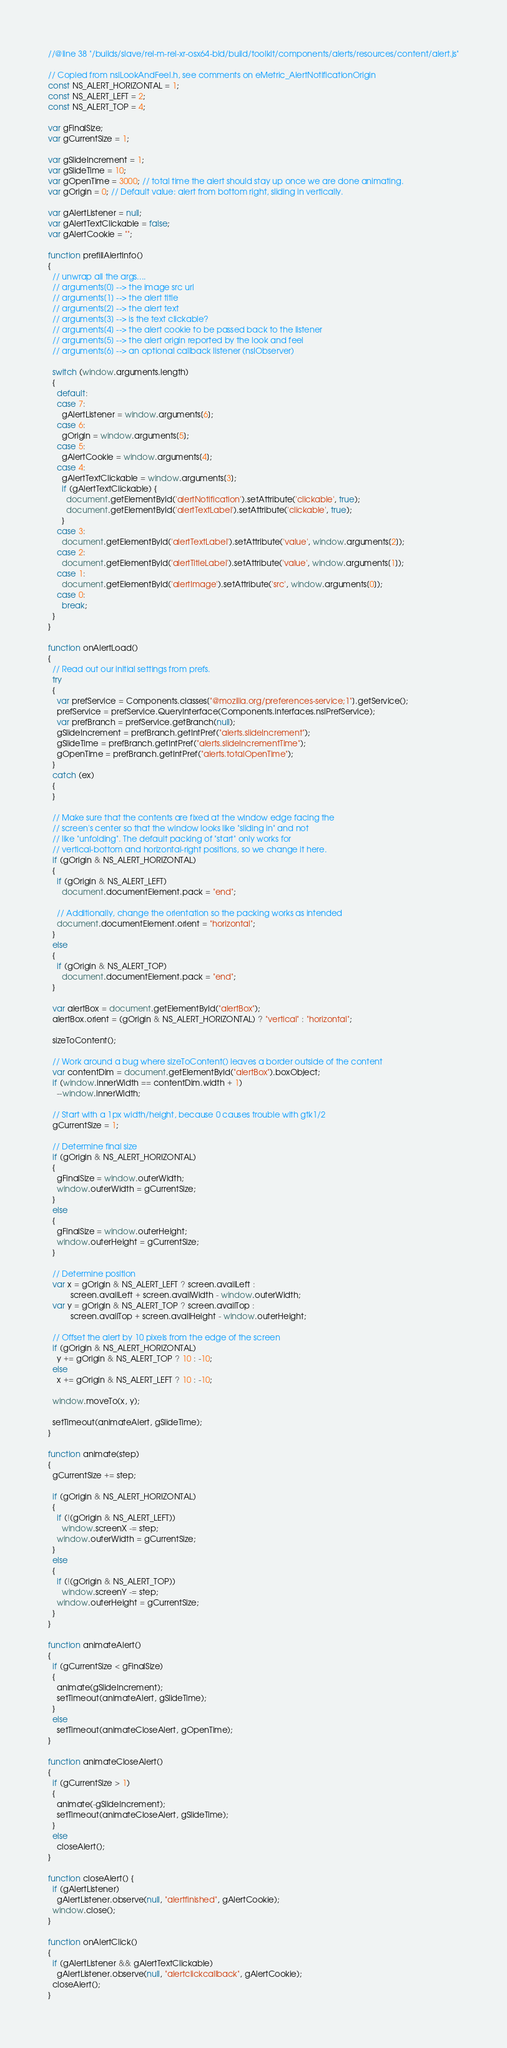Convert code to text. <code><loc_0><loc_0><loc_500><loc_500><_JavaScript_>//@line 38 "/builds/slave/rel-m-rel-xr-osx64-bld/build/toolkit/components/alerts/resources/content/alert.js"

// Copied from nsILookAndFeel.h, see comments on eMetric_AlertNotificationOrigin
const NS_ALERT_HORIZONTAL = 1;
const NS_ALERT_LEFT = 2;
const NS_ALERT_TOP = 4;

var gFinalSize;
var gCurrentSize = 1;

var gSlideIncrement = 1;
var gSlideTime = 10;
var gOpenTime = 3000; // total time the alert should stay up once we are done animating.
var gOrigin = 0; // Default value: alert from bottom right, sliding in vertically.

var gAlertListener = null;
var gAlertTextClickable = false;
var gAlertCookie = "";

function prefillAlertInfo()
{
  // unwrap all the args....
  // arguments[0] --> the image src url
  // arguments[1] --> the alert title
  // arguments[2] --> the alert text
  // arguments[3] --> is the text clickable? 
  // arguments[4] --> the alert cookie to be passed back to the listener
  // arguments[5] --> the alert origin reported by the look and feel
  // arguments[6] --> an optional callback listener (nsIObserver)

  switch (window.arguments.length)
  {
    default:
    case 7:
      gAlertListener = window.arguments[6];
    case 6:
      gOrigin = window.arguments[5];
    case 5:
      gAlertCookie = window.arguments[4];
    case 4:
      gAlertTextClickable = window.arguments[3];
      if (gAlertTextClickable) {
        document.getElementById('alertNotification').setAttribute('clickable', true);
        document.getElementById('alertTextLabel').setAttribute('clickable', true);
      }
    case 3:
      document.getElementById('alertTextLabel').setAttribute('value', window.arguments[2]);
    case 2:
      document.getElementById('alertTitleLabel').setAttribute('value', window.arguments[1]);
    case 1:
      document.getElementById('alertImage').setAttribute('src', window.arguments[0]);
    case 0:
      break;
  }
}

function onAlertLoad()
{
  // Read out our initial settings from prefs.
  try 
  {
    var prefService = Components.classes["@mozilla.org/preferences-service;1"].getService();
    prefService = prefService.QueryInterface(Components.interfaces.nsIPrefService);
    var prefBranch = prefService.getBranch(null);
    gSlideIncrement = prefBranch.getIntPref("alerts.slideIncrement");
    gSlideTime = prefBranch.getIntPref("alerts.slideIncrementTime");
    gOpenTime = prefBranch.getIntPref("alerts.totalOpenTime");
  }
  catch (ex)
  {
  }

  // Make sure that the contents are fixed at the window edge facing the
  // screen's center so that the window looks like "sliding in" and not
  // like "unfolding". The default packing of "start" only works for
  // vertical-bottom and horizontal-right positions, so we change it here.
  if (gOrigin & NS_ALERT_HORIZONTAL)
  {
    if (gOrigin & NS_ALERT_LEFT)
      document.documentElement.pack = "end";

    // Additionally, change the orientation so the packing works as intended
    document.documentElement.orient = "horizontal";
  }
  else
  {
    if (gOrigin & NS_ALERT_TOP)
      document.documentElement.pack = "end";
  }

  var alertBox = document.getElementById("alertBox");
  alertBox.orient = (gOrigin & NS_ALERT_HORIZONTAL) ? "vertical" : "horizontal";

  sizeToContent();

  // Work around a bug where sizeToContent() leaves a border outside of the content
  var contentDim = document.getElementById("alertBox").boxObject;
  if (window.innerWidth == contentDim.width + 1)
    --window.innerWidth;

  // Start with a 1px width/height, because 0 causes trouble with gtk1/2
  gCurrentSize = 1;

  // Determine final size
  if (gOrigin & NS_ALERT_HORIZONTAL)
  {
    gFinalSize = window.outerWidth;
    window.outerWidth = gCurrentSize;
  }
  else
  {
    gFinalSize = window.outerHeight;
    window.outerHeight = gCurrentSize;
  }

  // Determine position
  var x = gOrigin & NS_ALERT_LEFT ? screen.availLeft :
          screen.availLeft + screen.availWidth - window.outerWidth;
  var y = gOrigin & NS_ALERT_TOP ? screen.availTop :
          screen.availTop + screen.availHeight - window.outerHeight;

  // Offset the alert by 10 pixels from the edge of the screen
  if (gOrigin & NS_ALERT_HORIZONTAL)
    y += gOrigin & NS_ALERT_TOP ? 10 : -10;
  else
    x += gOrigin & NS_ALERT_LEFT ? 10 : -10;

  window.moveTo(x, y);

  setTimeout(animateAlert, gSlideTime);
}

function animate(step)
{
  gCurrentSize += step;

  if (gOrigin & NS_ALERT_HORIZONTAL)
  {
    if (!(gOrigin & NS_ALERT_LEFT))
      window.screenX -= step;
    window.outerWidth = gCurrentSize;
  }
  else
  {
    if (!(gOrigin & NS_ALERT_TOP))
      window.screenY -= step;
    window.outerHeight = gCurrentSize;
  }
}

function animateAlert()
{
  if (gCurrentSize < gFinalSize)
  {
    animate(gSlideIncrement);
    setTimeout(animateAlert, gSlideTime);
  }
  else
    setTimeout(animateCloseAlert, gOpenTime);  
}

function animateCloseAlert()
{
  if (gCurrentSize > 1)
  {
    animate(-gSlideIncrement);
    setTimeout(animateCloseAlert, gSlideTime);
  }
  else
    closeAlert();
}

function closeAlert() {
  if (gAlertListener)
    gAlertListener.observe(null, "alertfinished", gAlertCookie); 
  window.close(); 
}

function onAlertClick()
{
  if (gAlertListener && gAlertTextClickable)
    gAlertListener.observe(null, "alertclickcallback", gAlertCookie);
  closeAlert();
}
</code> 